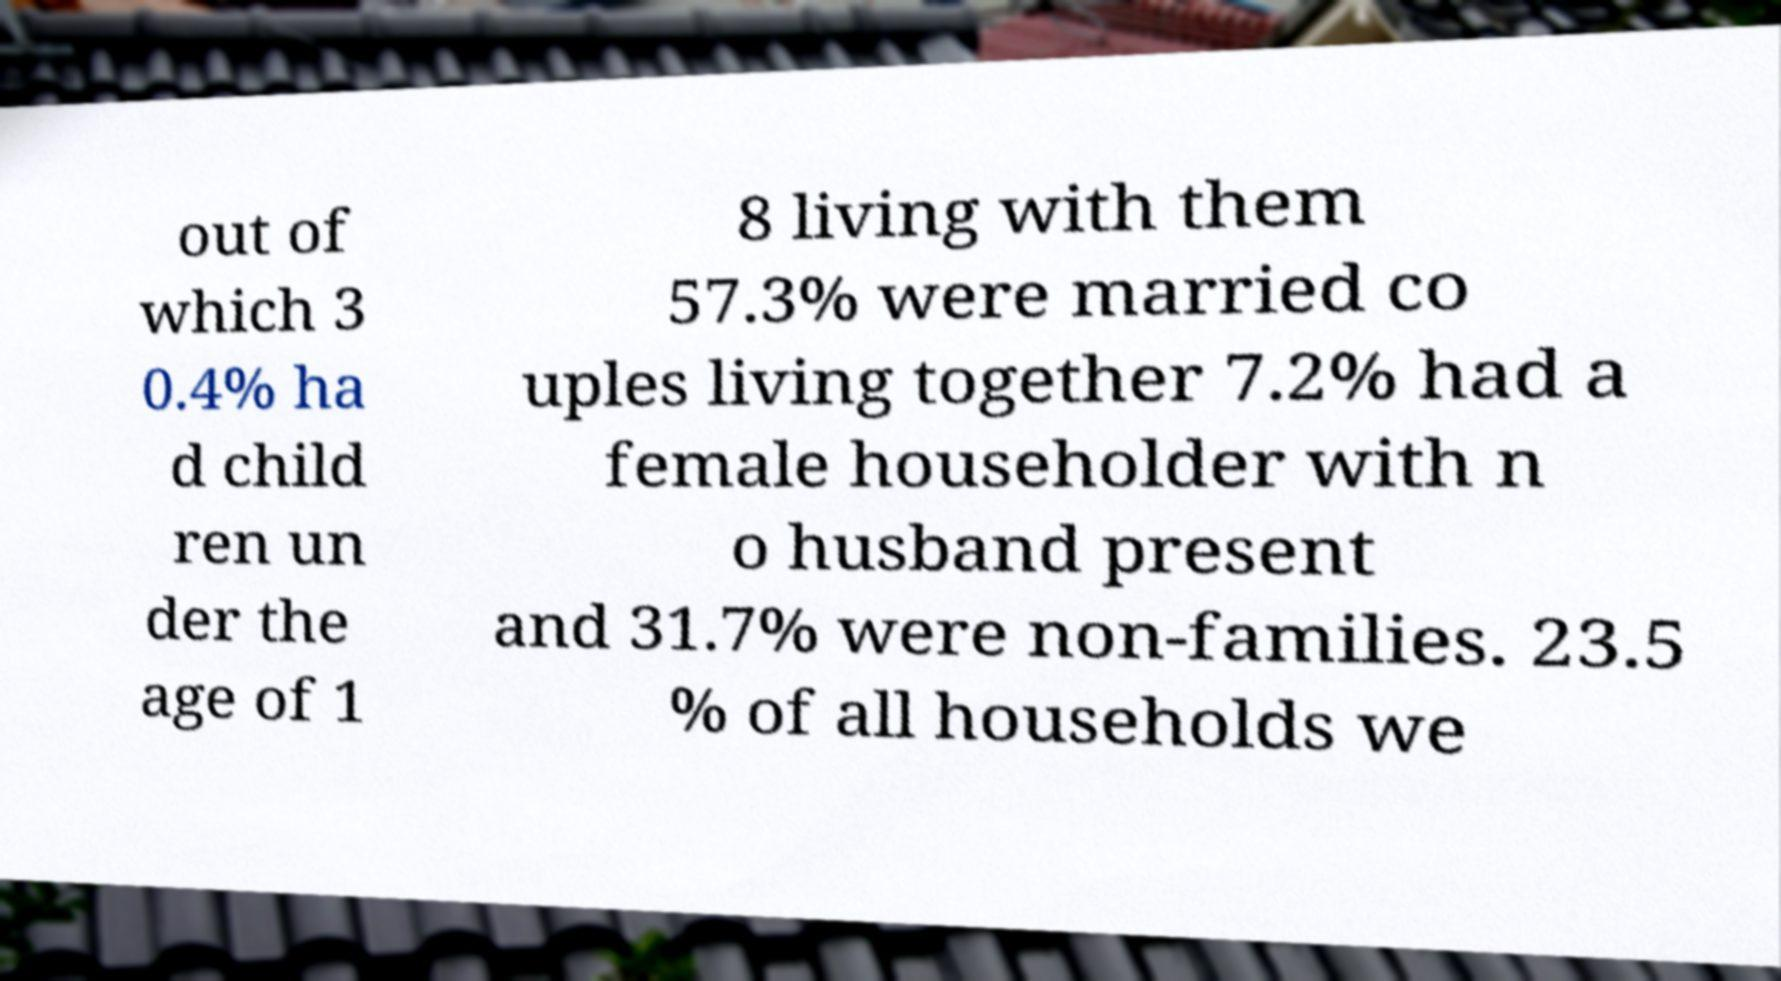Can you accurately transcribe the text from the provided image for me? out of which 3 0.4% ha d child ren un der the age of 1 8 living with them 57.3% were married co uples living together 7.2% had a female householder with n o husband present and 31.7% were non-families. 23.5 % of all households we 